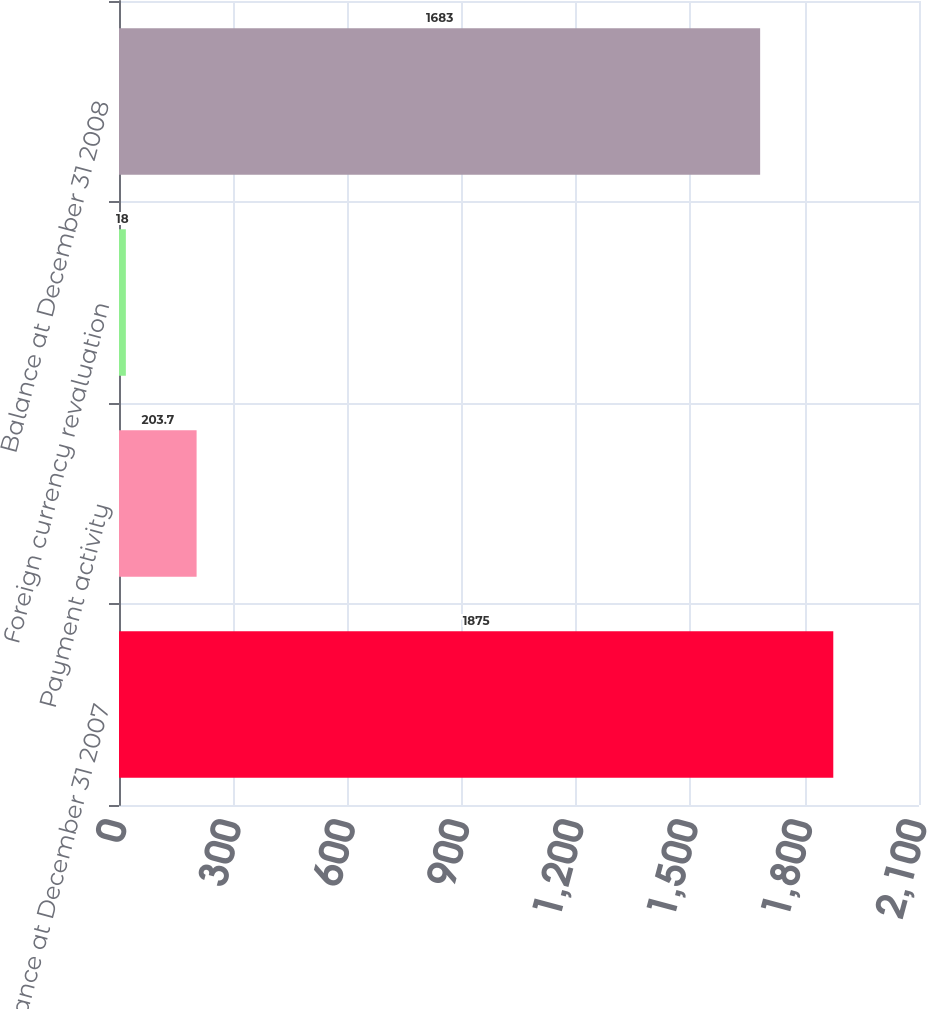Convert chart. <chart><loc_0><loc_0><loc_500><loc_500><bar_chart><fcel>Balance at December 31 2007<fcel>Payment activity<fcel>Foreign currency revaluation<fcel>Balance at December 31 2008<nl><fcel>1875<fcel>203.7<fcel>18<fcel>1683<nl></chart> 